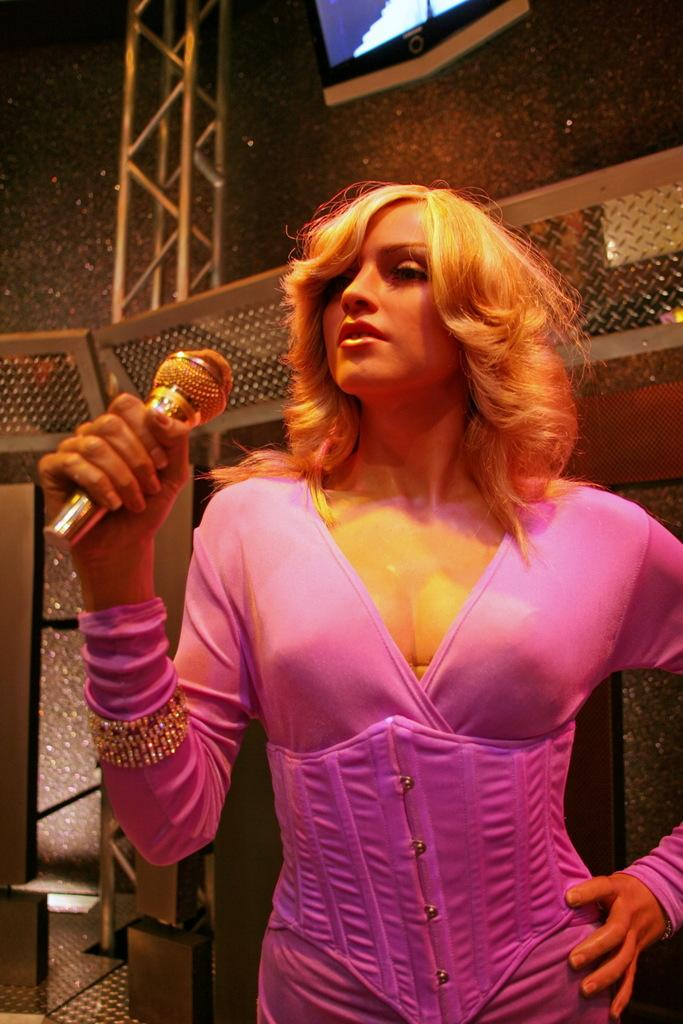Who is the main subject in the image? There is a woman in the image. What is the woman doing in the image? The woman is standing and holding a microphone. What can be seen in the background of the image? There is a railing in the background of the image. What type of celery is being used to fold the railing in the image? There is no celery present in the image, and the railing is not being folded. 